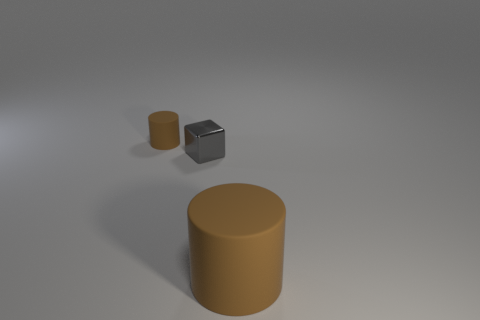What number of small cubes are right of the large rubber object?
Your answer should be compact. 0. There is a thing that is behind the big brown matte object and right of the small brown matte object; what is its size?
Your answer should be very brief. Small. Are there any gray metallic blocks?
Offer a very short reply. Yes. How many other things are there of the same size as the gray cube?
Make the answer very short. 1. Is the color of the matte cylinder that is in front of the tiny brown cylinder the same as the tiny object that is in front of the tiny brown rubber thing?
Provide a short and direct response. No. There is another brown matte object that is the same shape as the large brown thing; what size is it?
Ensure brevity in your answer.  Small. Is the material of the brown cylinder left of the large brown rubber cylinder the same as the gray block that is behind the large brown cylinder?
Make the answer very short. No. What number of shiny objects are either large cylinders or small brown objects?
Keep it short and to the point. 0. What material is the brown cylinder left of the brown thing right of the cylinder behind the large brown matte cylinder?
Keep it short and to the point. Rubber. Does the brown rubber object that is in front of the small brown rubber thing have the same shape as the tiny object that is in front of the small brown matte thing?
Your response must be concise. No. 